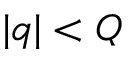<formula> <loc_0><loc_0><loc_500><loc_500>| q | < Q</formula> 